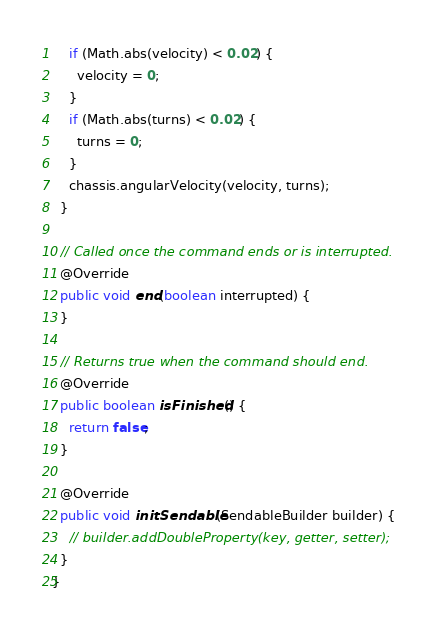Convert code to text. <code><loc_0><loc_0><loc_500><loc_500><_Java_>    if (Math.abs(velocity) < 0.02) {
      velocity = 0;
    }
    if (Math.abs(turns) < 0.02) {
      turns = 0;
    }
    chassis.angularVelocity(velocity, turns);
  }

  // Called once the command ends or is interrupted.
  @Override
  public void end(boolean interrupted) {
  }

  // Returns true when the command should end.
  @Override
  public boolean isFinished() {
    return false;
  }

  @Override
  public void initSendable(SendableBuilder builder) {
    // builder.addDoubleProperty(key, getter, setter);
  }
}
</code> 